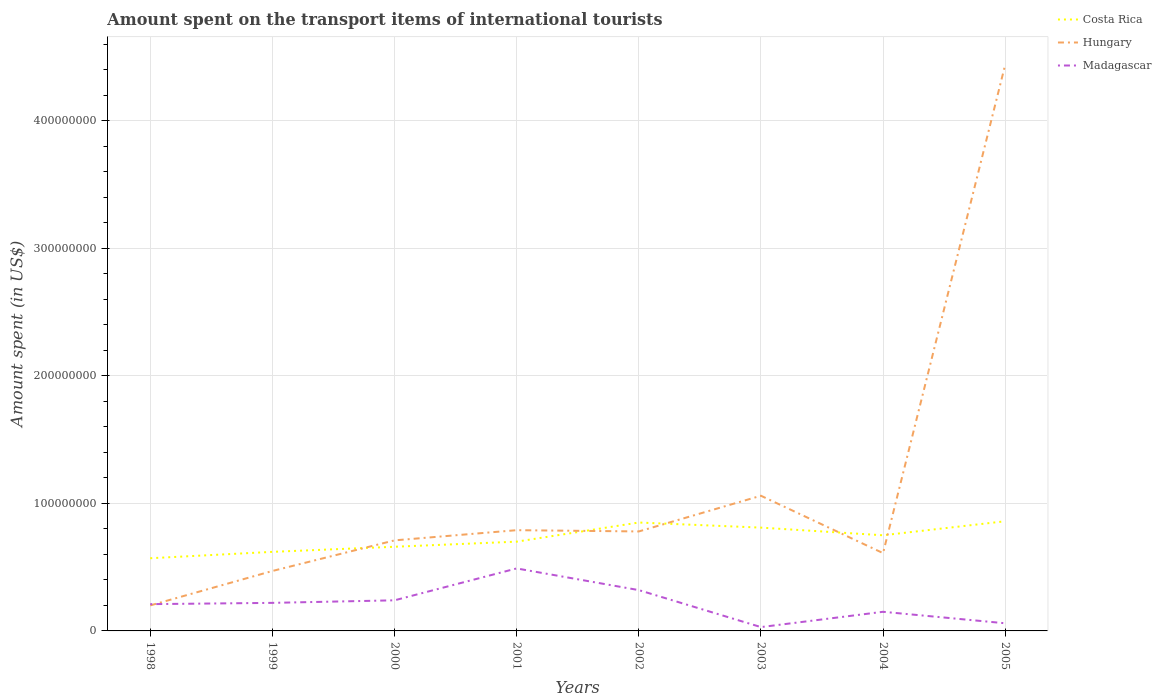Is the number of lines equal to the number of legend labels?
Ensure brevity in your answer.  Yes. Across all years, what is the maximum amount spent on the transport items of international tourists in Madagascar?
Your answer should be compact. 3.00e+06. In which year was the amount spent on the transport items of international tourists in Costa Rica maximum?
Give a very brief answer. 1998. What is the total amount spent on the transport items of international tourists in Costa Rica in the graph?
Give a very brief answer. 6.00e+06. What is the difference between the highest and the second highest amount spent on the transport items of international tourists in Madagascar?
Provide a succinct answer. 4.60e+07. Is the amount spent on the transport items of international tourists in Madagascar strictly greater than the amount spent on the transport items of international tourists in Hungary over the years?
Provide a short and direct response. No. How many lines are there?
Provide a succinct answer. 3. What is the difference between two consecutive major ticks on the Y-axis?
Offer a very short reply. 1.00e+08. Does the graph contain grids?
Keep it short and to the point. Yes. How are the legend labels stacked?
Ensure brevity in your answer.  Vertical. What is the title of the graph?
Offer a very short reply. Amount spent on the transport items of international tourists. Does "Dominica" appear as one of the legend labels in the graph?
Your answer should be compact. No. What is the label or title of the X-axis?
Make the answer very short. Years. What is the label or title of the Y-axis?
Ensure brevity in your answer.  Amount spent (in US$). What is the Amount spent (in US$) in Costa Rica in 1998?
Make the answer very short. 5.70e+07. What is the Amount spent (in US$) in Hungary in 1998?
Ensure brevity in your answer.  2.00e+07. What is the Amount spent (in US$) of Madagascar in 1998?
Offer a terse response. 2.10e+07. What is the Amount spent (in US$) of Costa Rica in 1999?
Offer a terse response. 6.20e+07. What is the Amount spent (in US$) of Hungary in 1999?
Your answer should be very brief. 4.70e+07. What is the Amount spent (in US$) of Madagascar in 1999?
Your response must be concise. 2.20e+07. What is the Amount spent (in US$) in Costa Rica in 2000?
Provide a succinct answer. 6.60e+07. What is the Amount spent (in US$) in Hungary in 2000?
Your response must be concise. 7.10e+07. What is the Amount spent (in US$) of Madagascar in 2000?
Offer a very short reply. 2.40e+07. What is the Amount spent (in US$) of Costa Rica in 2001?
Your answer should be very brief. 7.00e+07. What is the Amount spent (in US$) of Hungary in 2001?
Give a very brief answer. 7.90e+07. What is the Amount spent (in US$) in Madagascar in 2001?
Ensure brevity in your answer.  4.90e+07. What is the Amount spent (in US$) in Costa Rica in 2002?
Offer a terse response. 8.50e+07. What is the Amount spent (in US$) of Hungary in 2002?
Give a very brief answer. 7.80e+07. What is the Amount spent (in US$) of Madagascar in 2002?
Offer a terse response. 3.20e+07. What is the Amount spent (in US$) of Costa Rica in 2003?
Keep it short and to the point. 8.10e+07. What is the Amount spent (in US$) of Hungary in 2003?
Make the answer very short. 1.06e+08. What is the Amount spent (in US$) in Madagascar in 2003?
Your response must be concise. 3.00e+06. What is the Amount spent (in US$) in Costa Rica in 2004?
Keep it short and to the point. 7.50e+07. What is the Amount spent (in US$) in Hungary in 2004?
Your answer should be compact. 6.10e+07. What is the Amount spent (in US$) of Madagascar in 2004?
Your answer should be compact. 1.50e+07. What is the Amount spent (in US$) in Costa Rica in 2005?
Your answer should be compact. 8.60e+07. What is the Amount spent (in US$) of Hungary in 2005?
Make the answer very short. 4.44e+08. Across all years, what is the maximum Amount spent (in US$) in Costa Rica?
Provide a short and direct response. 8.60e+07. Across all years, what is the maximum Amount spent (in US$) of Hungary?
Your response must be concise. 4.44e+08. Across all years, what is the maximum Amount spent (in US$) in Madagascar?
Your answer should be very brief. 4.90e+07. Across all years, what is the minimum Amount spent (in US$) of Costa Rica?
Provide a succinct answer. 5.70e+07. Across all years, what is the minimum Amount spent (in US$) in Hungary?
Your answer should be compact. 2.00e+07. Across all years, what is the minimum Amount spent (in US$) in Madagascar?
Offer a terse response. 3.00e+06. What is the total Amount spent (in US$) in Costa Rica in the graph?
Provide a short and direct response. 5.82e+08. What is the total Amount spent (in US$) of Hungary in the graph?
Your response must be concise. 9.06e+08. What is the total Amount spent (in US$) of Madagascar in the graph?
Your response must be concise. 1.72e+08. What is the difference between the Amount spent (in US$) in Costa Rica in 1998 and that in 1999?
Provide a short and direct response. -5.00e+06. What is the difference between the Amount spent (in US$) of Hungary in 1998 and that in 1999?
Your answer should be very brief. -2.70e+07. What is the difference between the Amount spent (in US$) of Costa Rica in 1998 and that in 2000?
Keep it short and to the point. -9.00e+06. What is the difference between the Amount spent (in US$) in Hungary in 1998 and that in 2000?
Provide a succinct answer. -5.10e+07. What is the difference between the Amount spent (in US$) of Madagascar in 1998 and that in 2000?
Offer a very short reply. -3.00e+06. What is the difference between the Amount spent (in US$) in Costa Rica in 1998 and that in 2001?
Keep it short and to the point. -1.30e+07. What is the difference between the Amount spent (in US$) of Hungary in 1998 and that in 2001?
Offer a terse response. -5.90e+07. What is the difference between the Amount spent (in US$) of Madagascar in 1998 and that in 2001?
Provide a short and direct response. -2.80e+07. What is the difference between the Amount spent (in US$) in Costa Rica in 1998 and that in 2002?
Offer a very short reply. -2.80e+07. What is the difference between the Amount spent (in US$) in Hungary in 1998 and that in 2002?
Make the answer very short. -5.80e+07. What is the difference between the Amount spent (in US$) in Madagascar in 1998 and that in 2002?
Keep it short and to the point. -1.10e+07. What is the difference between the Amount spent (in US$) in Costa Rica in 1998 and that in 2003?
Offer a terse response. -2.40e+07. What is the difference between the Amount spent (in US$) of Hungary in 1998 and that in 2003?
Ensure brevity in your answer.  -8.60e+07. What is the difference between the Amount spent (in US$) of Madagascar in 1998 and that in 2003?
Offer a very short reply. 1.80e+07. What is the difference between the Amount spent (in US$) of Costa Rica in 1998 and that in 2004?
Ensure brevity in your answer.  -1.80e+07. What is the difference between the Amount spent (in US$) in Hungary in 1998 and that in 2004?
Provide a succinct answer. -4.10e+07. What is the difference between the Amount spent (in US$) in Costa Rica in 1998 and that in 2005?
Your answer should be very brief. -2.90e+07. What is the difference between the Amount spent (in US$) in Hungary in 1998 and that in 2005?
Your answer should be compact. -4.24e+08. What is the difference between the Amount spent (in US$) in Madagascar in 1998 and that in 2005?
Give a very brief answer. 1.50e+07. What is the difference between the Amount spent (in US$) of Costa Rica in 1999 and that in 2000?
Give a very brief answer. -4.00e+06. What is the difference between the Amount spent (in US$) in Hungary in 1999 and that in 2000?
Provide a short and direct response. -2.40e+07. What is the difference between the Amount spent (in US$) of Madagascar in 1999 and that in 2000?
Make the answer very short. -2.00e+06. What is the difference between the Amount spent (in US$) in Costa Rica in 1999 and that in 2001?
Your response must be concise. -8.00e+06. What is the difference between the Amount spent (in US$) of Hungary in 1999 and that in 2001?
Provide a succinct answer. -3.20e+07. What is the difference between the Amount spent (in US$) in Madagascar in 1999 and that in 2001?
Make the answer very short. -2.70e+07. What is the difference between the Amount spent (in US$) in Costa Rica in 1999 and that in 2002?
Your answer should be very brief. -2.30e+07. What is the difference between the Amount spent (in US$) of Hungary in 1999 and that in 2002?
Give a very brief answer. -3.10e+07. What is the difference between the Amount spent (in US$) in Madagascar in 1999 and that in 2002?
Provide a succinct answer. -1.00e+07. What is the difference between the Amount spent (in US$) in Costa Rica in 1999 and that in 2003?
Offer a very short reply. -1.90e+07. What is the difference between the Amount spent (in US$) of Hungary in 1999 and that in 2003?
Offer a very short reply. -5.90e+07. What is the difference between the Amount spent (in US$) in Madagascar in 1999 and that in 2003?
Ensure brevity in your answer.  1.90e+07. What is the difference between the Amount spent (in US$) of Costa Rica in 1999 and that in 2004?
Keep it short and to the point. -1.30e+07. What is the difference between the Amount spent (in US$) in Hungary in 1999 and that in 2004?
Ensure brevity in your answer.  -1.40e+07. What is the difference between the Amount spent (in US$) in Madagascar in 1999 and that in 2004?
Your answer should be compact. 7.00e+06. What is the difference between the Amount spent (in US$) of Costa Rica in 1999 and that in 2005?
Give a very brief answer. -2.40e+07. What is the difference between the Amount spent (in US$) in Hungary in 1999 and that in 2005?
Make the answer very short. -3.97e+08. What is the difference between the Amount spent (in US$) in Madagascar in 1999 and that in 2005?
Give a very brief answer. 1.60e+07. What is the difference between the Amount spent (in US$) in Hungary in 2000 and that in 2001?
Your answer should be very brief. -8.00e+06. What is the difference between the Amount spent (in US$) of Madagascar in 2000 and that in 2001?
Provide a short and direct response. -2.50e+07. What is the difference between the Amount spent (in US$) of Costa Rica in 2000 and that in 2002?
Keep it short and to the point. -1.90e+07. What is the difference between the Amount spent (in US$) in Hungary in 2000 and that in 2002?
Provide a short and direct response. -7.00e+06. What is the difference between the Amount spent (in US$) of Madagascar in 2000 and that in 2002?
Ensure brevity in your answer.  -8.00e+06. What is the difference between the Amount spent (in US$) of Costa Rica in 2000 and that in 2003?
Your answer should be very brief. -1.50e+07. What is the difference between the Amount spent (in US$) in Hungary in 2000 and that in 2003?
Keep it short and to the point. -3.50e+07. What is the difference between the Amount spent (in US$) in Madagascar in 2000 and that in 2003?
Provide a short and direct response. 2.10e+07. What is the difference between the Amount spent (in US$) in Costa Rica in 2000 and that in 2004?
Provide a short and direct response. -9.00e+06. What is the difference between the Amount spent (in US$) of Hungary in 2000 and that in 2004?
Offer a terse response. 1.00e+07. What is the difference between the Amount spent (in US$) in Madagascar in 2000 and that in 2004?
Your answer should be very brief. 9.00e+06. What is the difference between the Amount spent (in US$) of Costa Rica in 2000 and that in 2005?
Keep it short and to the point. -2.00e+07. What is the difference between the Amount spent (in US$) of Hungary in 2000 and that in 2005?
Offer a terse response. -3.73e+08. What is the difference between the Amount spent (in US$) in Madagascar in 2000 and that in 2005?
Provide a succinct answer. 1.80e+07. What is the difference between the Amount spent (in US$) in Costa Rica in 2001 and that in 2002?
Offer a terse response. -1.50e+07. What is the difference between the Amount spent (in US$) of Hungary in 2001 and that in 2002?
Your answer should be compact. 1.00e+06. What is the difference between the Amount spent (in US$) of Madagascar in 2001 and that in 2002?
Provide a succinct answer. 1.70e+07. What is the difference between the Amount spent (in US$) of Costa Rica in 2001 and that in 2003?
Make the answer very short. -1.10e+07. What is the difference between the Amount spent (in US$) in Hungary in 2001 and that in 2003?
Keep it short and to the point. -2.70e+07. What is the difference between the Amount spent (in US$) in Madagascar in 2001 and that in 2003?
Make the answer very short. 4.60e+07. What is the difference between the Amount spent (in US$) in Costa Rica in 2001 and that in 2004?
Provide a succinct answer. -5.00e+06. What is the difference between the Amount spent (in US$) of Hungary in 2001 and that in 2004?
Provide a short and direct response. 1.80e+07. What is the difference between the Amount spent (in US$) in Madagascar in 2001 and that in 2004?
Give a very brief answer. 3.40e+07. What is the difference between the Amount spent (in US$) of Costa Rica in 2001 and that in 2005?
Your response must be concise. -1.60e+07. What is the difference between the Amount spent (in US$) in Hungary in 2001 and that in 2005?
Your response must be concise. -3.65e+08. What is the difference between the Amount spent (in US$) in Madagascar in 2001 and that in 2005?
Make the answer very short. 4.30e+07. What is the difference between the Amount spent (in US$) in Costa Rica in 2002 and that in 2003?
Ensure brevity in your answer.  4.00e+06. What is the difference between the Amount spent (in US$) in Hungary in 2002 and that in 2003?
Give a very brief answer. -2.80e+07. What is the difference between the Amount spent (in US$) in Madagascar in 2002 and that in 2003?
Your answer should be very brief. 2.90e+07. What is the difference between the Amount spent (in US$) of Costa Rica in 2002 and that in 2004?
Keep it short and to the point. 1.00e+07. What is the difference between the Amount spent (in US$) in Hungary in 2002 and that in 2004?
Your answer should be compact. 1.70e+07. What is the difference between the Amount spent (in US$) in Madagascar in 2002 and that in 2004?
Give a very brief answer. 1.70e+07. What is the difference between the Amount spent (in US$) in Hungary in 2002 and that in 2005?
Offer a terse response. -3.66e+08. What is the difference between the Amount spent (in US$) of Madagascar in 2002 and that in 2005?
Make the answer very short. 2.60e+07. What is the difference between the Amount spent (in US$) in Costa Rica in 2003 and that in 2004?
Your answer should be very brief. 6.00e+06. What is the difference between the Amount spent (in US$) in Hungary in 2003 and that in 2004?
Your answer should be very brief. 4.50e+07. What is the difference between the Amount spent (in US$) in Madagascar in 2003 and that in 2004?
Ensure brevity in your answer.  -1.20e+07. What is the difference between the Amount spent (in US$) in Costa Rica in 2003 and that in 2005?
Your response must be concise. -5.00e+06. What is the difference between the Amount spent (in US$) in Hungary in 2003 and that in 2005?
Make the answer very short. -3.38e+08. What is the difference between the Amount spent (in US$) in Madagascar in 2003 and that in 2005?
Your response must be concise. -3.00e+06. What is the difference between the Amount spent (in US$) of Costa Rica in 2004 and that in 2005?
Make the answer very short. -1.10e+07. What is the difference between the Amount spent (in US$) of Hungary in 2004 and that in 2005?
Make the answer very short. -3.83e+08. What is the difference between the Amount spent (in US$) of Madagascar in 2004 and that in 2005?
Your answer should be compact. 9.00e+06. What is the difference between the Amount spent (in US$) of Costa Rica in 1998 and the Amount spent (in US$) of Madagascar in 1999?
Keep it short and to the point. 3.50e+07. What is the difference between the Amount spent (in US$) of Costa Rica in 1998 and the Amount spent (in US$) of Hungary in 2000?
Keep it short and to the point. -1.40e+07. What is the difference between the Amount spent (in US$) in Costa Rica in 1998 and the Amount spent (in US$) in Madagascar in 2000?
Keep it short and to the point. 3.30e+07. What is the difference between the Amount spent (in US$) of Costa Rica in 1998 and the Amount spent (in US$) of Hungary in 2001?
Your answer should be compact. -2.20e+07. What is the difference between the Amount spent (in US$) of Hungary in 1998 and the Amount spent (in US$) of Madagascar in 2001?
Provide a succinct answer. -2.90e+07. What is the difference between the Amount spent (in US$) of Costa Rica in 1998 and the Amount spent (in US$) of Hungary in 2002?
Your answer should be compact. -2.10e+07. What is the difference between the Amount spent (in US$) of Costa Rica in 1998 and the Amount spent (in US$) of Madagascar in 2002?
Offer a terse response. 2.50e+07. What is the difference between the Amount spent (in US$) of Hungary in 1998 and the Amount spent (in US$) of Madagascar in 2002?
Ensure brevity in your answer.  -1.20e+07. What is the difference between the Amount spent (in US$) of Costa Rica in 1998 and the Amount spent (in US$) of Hungary in 2003?
Give a very brief answer. -4.90e+07. What is the difference between the Amount spent (in US$) in Costa Rica in 1998 and the Amount spent (in US$) in Madagascar in 2003?
Give a very brief answer. 5.40e+07. What is the difference between the Amount spent (in US$) in Hungary in 1998 and the Amount spent (in US$) in Madagascar in 2003?
Ensure brevity in your answer.  1.70e+07. What is the difference between the Amount spent (in US$) of Costa Rica in 1998 and the Amount spent (in US$) of Madagascar in 2004?
Provide a short and direct response. 4.20e+07. What is the difference between the Amount spent (in US$) in Hungary in 1998 and the Amount spent (in US$) in Madagascar in 2004?
Offer a terse response. 5.00e+06. What is the difference between the Amount spent (in US$) in Costa Rica in 1998 and the Amount spent (in US$) in Hungary in 2005?
Make the answer very short. -3.87e+08. What is the difference between the Amount spent (in US$) of Costa Rica in 1998 and the Amount spent (in US$) of Madagascar in 2005?
Give a very brief answer. 5.10e+07. What is the difference between the Amount spent (in US$) in Hungary in 1998 and the Amount spent (in US$) in Madagascar in 2005?
Offer a terse response. 1.40e+07. What is the difference between the Amount spent (in US$) in Costa Rica in 1999 and the Amount spent (in US$) in Hungary in 2000?
Make the answer very short. -9.00e+06. What is the difference between the Amount spent (in US$) in Costa Rica in 1999 and the Amount spent (in US$) in Madagascar in 2000?
Your answer should be compact. 3.80e+07. What is the difference between the Amount spent (in US$) of Hungary in 1999 and the Amount spent (in US$) of Madagascar in 2000?
Keep it short and to the point. 2.30e+07. What is the difference between the Amount spent (in US$) of Costa Rica in 1999 and the Amount spent (in US$) of Hungary in 2001?
Offer a very short reply. -1.70e+07. What is the difference between the Amount spent (in US$) of Costa Rica in 1999 and the Amount spent (in US$) of Madagascar in 2001?
Provide a short and direct response. 1.30e+07. What is the difference between the Amount spent (in US$) of Costa Rica in 1999 and the Amount spent (in US$) of Hungary in 2002?
Your answer should be very brief. -1.60e+07. What is the difference between the Amount spent (in US$) in Costa Rica in 1999 and the Amount spent (in US$) in Madagascar in 2002?
Provide a succinct answer. 3.00e+07. What is the difference between the Amount spent (in US$) in Hungary in 1999 and the Amount spent (in US$) in Madagascar in 2002?
Offer a very short reply. 1.50e+07. What is the difference between the Amount spent (in US$) in Costa Rica in 1999 and the Amount spent (in US$) in Hungary in 2003?
Offer a terse response. -4.40e+07. What is the difference between the Amount spent (in US$) in Costa Rica in 1999 and the Amount spent (in US$) in Madagascar in 2003?
Provide a short and direct response. 5.90e+07. What is the difference between the Amount spent (in US$) of Hungary in 1999 and the Amount spent (in US$) of Madagascar in 2003?
Provide a short and direct response. 4.40e+07. What is the difference between the Amount spent (in US$) in Costa Rica in 1999 and the Amount spent (in US$) in Madagascar in 2004?
Offer a very short reply. 4.70e+07. What is the difference between the Amount spent (in US$) of Hungary in 1999 and the Amount spent (in US$) of Madagascar in 2004?
Give a very brief answer. 3.20e+07. What is the difference between the Amount spent (in US$) of Costa Rica in 1999 and the Amount spent (in US$) of Hungary in 2005?
Ensure brevity in your answer.  -3.82e+08. What is the difference between the Amount spent (in US$) of Costa Rica in 1999 and the Amount spent (in US$) of Madagascar in 2005?
Your answer should be very brief. 5.60e+07. What is the difference between the Amount spent (in US$) in Hungary in 1999 and the Amount spent (in US$) in Madagascar in 2005?
Provide a succinct answer. 4.10e+07. What is the difference between the Amount spent (in US$) in Costa Rica in 2000 and the Amount spent (in US$) in Hungary in 2001?
Provide a short and direct response. -1.30e+07. What is the difference between the Amount spent (in US$) in Costa Rica in 2000 and the Amount spent (in US$) in Madagascar in 2001?
Keep it short and to the point. 1.70e+07. What is the difference between the Amount spent (in US$) of Hungary in 2000 and the Amount spent (in US$) of Madagascar in 2001?
Ensure brevity in your answer.  2.20e+07. What is the difference between the Amount spent (in US$) in Costa Rica in 2000 and the Amount spent (in US$) in Hungary in 2002?
Provide a succinct answer. -1.20e+07. What is the difference between the Amount spent (in US$) in Costa Rica in 2000 and the Amount spent (in US$) in Madagascar in 2002?
Make the answer very short. 3.40e+07. What is the difference between the Amount spent (in US$) in Hungary in 2000 and the Amount spent (in US$) in Madagascar in 2002?
Your answer should be very brief. 3.90e+07. What is the difference between the Amount spent (in US$) of Costa Rica in 2000 and the Amount spent (in US$) of Hungary in 2003?
Make the answer very short. -4.00e+07. What is the difference between the Amount spent (in US$) in Costa Rica in 2000 and the Amount spent (in US$) in Madagascar in 2003?
Provide a short and direct response. 6.30e+07. What is the difference between the Amount spent (in US$) of Hungary in 2000 and the Amount spent (in US$) of Madagascar in 2003?
Provide a succinct answer. 6.80e+07. What is the difference between the Amount spent (in US$) in Costa Rica in 2000 and the Amount spent (in US$) in Madagascar in 2004?
Provide a succinct answer. 5.10e+07. What is the difference between the Amount spent (in US$) in Hungary in 2000 and the Amount spent (in US$) in Madagascar in 2004?
Keep it short and to the point. 5.60e+07. What is the difference between the Amount spent (in US$) of Costa Rica in 2000 and the Amount spent (in US$) of Hungary in 2005?
Provide a succinct answer. -3.78e+08. What is the difference between the Amount spent (in US$) in Costa Rica in 2000 and the Amount spent (in US$) in Madagascar in 2005?
Your answer should be compact. 6.00e+07. What is the difference between the Amount spent (in US$) in Hungary in 2000 and the Amount spent (in US$) in Madagascar in 2005?
Make the answer very short. 6.50e+07. What is the difference between the Amount spent (in US$) of Costa Rica in 2001 and the Amount spent (in US$) of Hungary in 2002?
Make the answer very short. -8.00e+06. What is the difference between the Amount spent (in US$) in Costa Rica in 2001 and the Amount spent (in US$) in Madagascar in 2002?
Offer a very short reply. 3.80e+07. What is the difference between the Amount spent (in US$) of Hungary in 2001 and the Amount spent (in US$) of Madagascar in 2002?
Provide a succinct answer. 4.70e+07. What is the difference between the Amount spent (in US$) in Costa Rica in 2001 and the Amount spent (in US$) in Hungary in 2003?
Make the answer very short. -3.60e+07. What is the difference between the Amount spent (in US$) of Costa Rica in 2001 and the Amount spent (in US$) of Madagascar in 2003?
Provide a succinct answer. 6.70e+07. What is the difference between the Amount spent (in US$) of Hungary in 2001 and the Amount spent (in US$) of Madagascar in 2003?
Make the answer very short. 7.60e+07. What is the difference between the Amount spent (in US$) of Costa Rica in 2001 and the Amount spent (in US$) of Hungary in 2004?
Make the answer very short. 9.00e+06. What is the difference between the Amount spent (in US$) in Costa Rica in 2001 and the Amount spent (in US$) in Madagascar in 2004?
Offer a very short reply. 5.50e+07. What is the difference between the Amount spent (in US$) in Hungary in 2001 and the Amount spent (in US$) in Madagascar in 2004?
Ensure brevity in your answer.  6.40e+07. What is the difference between the Amount spent (in US$) in Costa Rica in 2001 and the Amount spent (in US$) in Hungary in 2005?
Your response must be concise. -3.74e+08. What is the difference between the Amount spent (in US$) of Costa Rica in 2001 and the Amount spent (in US$) of Madagascar in 2005?
Your response must be concise. 6.40e+07. What is the difference between the Amount spent (in US$) in Hungary in 2001 and the Amount spent (in US$) in Madagascar in 2005?
Give a very brief answer. 7.30e+07. What is the difference between the Amount spent (in US$) in Costa Rica in 2002 and the Amount spent (in US$) in Hungary in 2003?
Provide a short and direct response. -2.10e+07. What is the difference between the Amount spent (in US$) of Costa Rica in 2002 and the Amount spent (in US$) of Madagascar in 2003?
Your response must be concise. 8.20e+07. What is the difference between the Amount spent (in US$) in Hungary in 2002 and the Amount spent (in US$) in Madagascar in 2003?
Your answer should be very brief. 7.50e+07. What is the difference between the Amount spent (in US$) of Costa Rica in 2002 and the Amount spent (in US$) of Hungary in 2004?
Give a very brief answer. 2.40e+07. What is the difference between the Amount spent (in US$) of Costa Rica in 2002 and the Amount spent (in US$) of Madagascar in 2004?
Your answer should be compact. 7.00e+07. What is the difference between the Amount spent (in US$) of Hungary in 2002 and the Amount spent (in US$) of Madagascar in 2004?
Your response must be concise. 6.30e+07. What is the difference between the Amount spent (in US$) of Costa Rica in 2002 and the Amount spent (in US$) of Hungary in 2005?
Keep it short and to the point. -3.59e+08. What is the difference between the Amount spent (in US$) in Costa Rica in 2002 and the Amount spent (in US$) in Madagascar in 2005?
Provide a succinct answer. 7.90e+07. What is the difference between the Amount spent (in US$) in Hungary in 2002 and the Amount spent (in US$) in Madagascar in 2005?
Your answer should be very brief. 7.20e+07. What is the difference between the Amount spent (in US$) in Costa Rica in 2003 and the Amount spent (in US$) in Hungary in 2004?
Give a very brief answer. 2.00e+07. What is the difference between the Amount spent (in US$) in Costa Rica in 2003 and the Amount spent (in US$) in Madagascar in 2004?
Your answer should be very brief. 6.60e+07. What is the difference between the Amount spent (in US$) in Hungary in 2003 and the Amount spent (in US$) in Madagascar in 2004?
Your response must be concise. 9.10e+07. What is the difference between the Amount spent (in US$) of Costa Rica in 2003 and the Amount spent (in US$) of Hungary in 2005?
Provide a short and direct response. -3.63e+08. What is the difference between the Amount spent (in US$) of Costa Rica in 2003 and the Amount spent (in US$) of Madagascar in 2005?
Ensure brevity in your answer.  7.50e+07. What is the difference between the Amount spent (in US$) of Hungary in 2003 and the Amount spent (in US$) of Madagascar in 2005?
Your answer should be compact. 1.00e+08. What is the difference between the Amount spent (in US$) of Costa Rica in 2004 and the Amount spent (in US$) of Hungary in 2005?
Your answer should be compact. -3.69e+08. What is the difference between the Amount spent (in US$) of Costa Rica in 2004 and the Amount spent (in US$) of Madagascar in 2005?
Offer a very short reply. 6.90e+07. What is the difference between the Amount spent (in US$) in Hungary in 2004 and the Amount spent (in US$) in Madagascar in 2005?
Ensure brevity in your answer.  5.50e+07. What is the average Amount spent (in US$) in Costa Rica per year?
Your answer should be very brief. 7.28e+07. What is the average Amount spent (in US$) in Hungary per year?
Make the answer very short. 1.13e+08. What is the average Amount spent (in US$) of Madagascar per year?
Your answer should be compact. 2.15e+07. In the year 1998, what is the difference between the Amount spent (in US$) of Costa Rica and Amount spent (in US$) of Hungary?
Your answer should be compact. 3.70e+07. In the year 1998, what is the difference between the Amount spent (in US$) in Costa Rica and Amount spent (in US$) in Madagascar?
Ensure brevity in your answer.  3.60e+07. In the year 1998, what is the difference between the Amount spent (in US$) in Hungary and Amount spent (in US$) in Madagascar?
Your response must be concise. -1.00e+06. In the year 1999, what is the difference between the Amount spent (in US$) in Costa Rica and Amount spent (in US$) in Hungary?
Your answer should be compact. 1.50e+07. In the year 1999, what is the difference between the Amount spent (in US$) in Costa Rica and Amount spent (in US$) in Madagascar?
Ensure brevity in your answer.  4.00e+07. In the year 1999, what is the difference between the Amount spent (in US$) in Hungary and Amount spent (in US$) in Madagascar?
Give a very brief answer. 2.50e+07. In the year 2000, what is the difference between the Amount spent (in US$) in Costa Rica and Amount spent (in US$) in Hungary?
Your response must be concise. -5.00e+06. In the year 2000, what is the difference between the Amount spent (in US$) of Costa Rica and Amount spent (in US$) of Madagascar?
Provide a short and direct response. 4.20e+07. In the year 2000, what is the difference between the Amount spent (in US$) of Hungary and Amount spent (in US$) of Madagascar?
Offer a terse response. 4.70e+07. In the year 2001, what is the difference between the Amount spent (in US$) in Costa Rica and Amount spent (in US$) in Hungary?
Ensure brevity in your answer.  -9.00e+06. In the year 2001, what is the difference between the Amount spent (in US$) of Costa Rica and Amount spent (in US$) of Madagascar?
Make the answer very short. 2.10e+07. In the year 2001, what is the difference between the Amount spent (in US$) in Hungary and Amount spent (in US$) in Madagascar?
Ensure brevity in your answer.  3.00e+07. In the year 2002, what is the difference between the Amount spent (in US$) in Costa Rica and Amount spent (in US$) in Hungary?
Offer a terse response. 7.00e+06. In the year 2002, what is the difference between the Amount spent (in US$) in Costa Rica and Amount spent (in US$) in Madagascar?
Offer a terse response. 5.30e+07. In the year 2002, what is the difference between the Amount spent (in US$) of Hungary and Amount spent (in US$) of Madagascar?
Provide a short and direct response. 4.60e+07. In the year 2003, what is the difference between the Amount spent (in US$) of Costa Rica and Amount spent (in US$) of Hungary?
Offer a very short reply. -2.50e+07. In the year 2003, what is the difference between the Amount spent (in US$) in Costa Rica and Amount spent (in US$) in Madagascar?
Provide a succinct answer. 7.80e+07. In the year 2003, what is the difference between the Amount spent (in US$) of Hungary and Amount spent (in US$) of Madagascar?
Provide a short and direct response. 1.03e+08. In the year 2004, what is the difference between the Amount spent (in US$) of Costa Rica and Amount spent (in US$) of Hungary?
Offer a terse response. 1.40e+07. In the year 2004, what is the difference between the Amount spent (in US$) of Costa Rica and Amount spent (in US$) of Madagascar?
Your answer should be compact. 6.00e+07. In the year 2004, what is the difference between the Amount spent (in US$) of Hungary and Amount spent (in US$) of Madagascar?
Make the answer very short. 4.60e+07. In the year 2005, what is the difference between the Amount spent (in US$) in Costa Rica and Amount spent (in US$) in Hungary?
Ensure brevity in your answer.  -3.58e+08. In the year 2005, what is the difference between the Amount spent (in US$) of Costa Rica and Amount spent (in US$) of Madagascar?
Offer a very short reply. 8.00e+07. In the year 2005, what is the difference between the Amount spent (in US$) of Hungary and Amount spent (in US$) of Madagascar?
Your response must be concise. 4.38e+08. What is the ratio of the Amount spent (in US$) in Costa Rica in 1998 to that in 1999?
Offer a very short reply. 0.92. What is the ratio of the Amount spent (in US$) of Hungary in 1998 to that in 1999?
Your answer should be compact. 0.43. What is the ratio of the Amount spent (in US$) of Madagascar in 1998 to that in 1999?
Your answer should be compact. 0.95. What is the ratio of the Amount spent (in US$) in Costa Rica in 1998 to that in 2000?
Your response must be concise. 0.86. What is the ratio of the Amount spent (in US$) in Hungary in 1998 to that in 2000?
Your answer should be compact. 0.28. What is the ratio of the Amount spent (in US$) in Costa Rica in 1998 to that in 2001?
Your answer should be compact. 0.81. What is the ratio of the Amount spent (in US$) of Hungary in 1998 to that in 2001?
Your response must be concise. 0.25. What is the ratio of the Amount spent (in US$) of Madagascar in 1998 to that in 2001?
Ensure brevity in your answer.  0.43. What is the ratio of the Amount spent (in US$) in Costa Rica in 1998 to that in 2002?
Give a very brief answer. 0.67. What is the ratio of the Amount spent (in US$) in Hungary in 1998 to that in 2002?
Your answer should be very brief. 0.26. What is the ratio of the Amount spent (in US$) of Madagascar in 1998 to that in 2002?
Your answer should be compact. 0.66. What is the ratio of the Amount spent (in US$) of Costa Rica in 1998 to that in 2003?
Ensure brevity in your answer.  0.7. What is the ratio of the Amount spent (in US$) in Hungary in 1998 to that in 2003?
Give a very brief answer. 0.19. What is the ratio of the Amount spent (in US$) of Madagascar in 1998 to that in 2003?
Your response must be concise. 7. What is the ratio of the Amount spent (in US$) in Costa Rica in 1998 to that in 2004?
Offer a very short reply. 0.76. What is the ratio of the Amount spent (in US$) of Hungary in 1998 to that in 2004?
Keep it short and to the point. 0.33. What is the ratio of the Amount spent (in US$) in Costa Rica in 1998 to that in 2005?
Your answer should be very brief. 0.66. What is the ratio of the Amount spent (in US$) in Hungary in 1998 to that in 2005?
Keep it short and to the point. 0.04. What is the ratio of the Amount spent (in US$) of Madagascar in 1998 to that in 2005?
Your response must be concise. 3.5. What is the ratio of the Amount spent (in US$) in Costa Rica in 1999 to that in 2000?
Provide a succinct answer. 0.94. What is the ratio of the Amount spent (in US$) of Hungary in 1999 to that in 2000?
Keep it short and to the point. 0.66. What is the ratio of the Amount spent (in US$) in Madagascar in 1999 to that in 2000?
Provide a succinct answer. 0.92. What is the ratio of the Amount spent (in US$) in Costa Rica in 1999 to that in 2001?
Make the answer very short. 0.89. What is the ratio of the Amount spent (in US$) in Hungary in 1999 to that in 2001?
Your answer should be very brief. 0.59. What is the ratio of the Amount spent (in US$) in Madagascar in 1999 to that in 2001?
Ensure brevity in your answer.  0.45. What is the ratio of the Amount spent (in US$) of Costa Rica in 1999 to that in 2002?
Provide a succinct answer. 0.73. What is the ratio of the Amount spent (in US$) of Hungary in 1999 to that in 2002?
Make the answer very short. 0.6. What is the ratio of the Amount spent (in US$) of Madagascar in 1999 to that in 2002?
Give a very brief answer. 0.69. What is the ratio of the Amount spent (in US$) of Costa Rica in 1999 to that in 2003?
Offer a very short reply. 0.77. What is the ratio of the Amount spent (in US$) in Hungary in 1999 to that in 2003?
Offer a terse response. 0.44. What is the ratio of the Amount spent (in US$) of Madagascar in 1999 to that in 2003?
Give a very brief answer. 7.33. What is the ratio of the Amount spent (in US$) in Costa Rica in 1999 to that in 2004?
Offer a very short reply. 0.83. What is the ratio of the Amount spent (in US$) of Hungary in 1999 to that in 2004?
Your answer should be compact. 0.77. What is the ratio of the Amount spent (in US$) in Madagascar in 1999 to that in 2004?
Give a very brief answer. 1.47. What is the ratio of the Amount spent (in US$) of Costa Rica in 1999 to that in 2005?
Keep it short and to the point. 0.72. What is the ratio of the Amount spent (in US$) of Hungary in 1999 to that in 2005?
Give a very brief answer. 0.11. What is the ratio of the Amount spent (in US$) of Madagascar in 1999 to that in 2005?
Offer a very short reply. 3.67. What is the ratio of the Amount spent (in US$) in Costa Rica in 2000 to that in 2001?
Provide a succinct answer. 0.94. What is the ratio of the Amount spent (in US$) in Hungary in 2000 to that in 2001?
Provide a succinct answer. 0.9. What is the ratio of the Amount spent (in US$) in Madagascar in 2000 to that in 2001?
Keep it short and to the point. 0.49. What is the ratio of the Amount spent (in US$) in Costa Rica in 2000 to that in 2002?
Your answer should be very brief. 0.78. What is the ratio of the Amount spent (in US$) in Hungary in 2000 to that in 2002?
Make the answer very short. 0.91. What is the ratio of the Amount spent (in US$) of Costa Rica in 2000 to that in 2003?
Your answer should be very brief. 0.81. What is the ratio of the Amount spent (in US$) of Hungary in 2000 to that in 2003?
Your answer should be compact. 0.67. What is the ratio of the Amount spent (in US$) in Madagascar in 2000 to that in 2003?
Ensure brevity in your answer.  8. What is the ratio of the Amount spent (in US$) in Costa Rica in 2000 to that in 2004?
Your answer should be compact. 0.88. What is the ratio of the Amount spent (in US$) in Hungary in 2000 to that in 2004?
Provide a succinct answer. 1.16. What is the ratio of the Amount spent (in US$) of Costa Rica in 2000 to that in 2005?
Ensure brevity in your answer.  0.77. What is the ratio of the Amount spent (in US$) of Hungary in 2000 to that in 2005?
Provide a succinct answer. 0.16. What is the ratio of the Amount spent (in US$) in Madagascar in 2000 to that in 2005?
Offer a very short reply. 4. What is the ratio of the Amount spent (in US$) in Costa Rica in 2001 to that in 2002?
Make the answer very short. 0.82. What is the ratio of the Amount spent (in US$) in Hungary in 2001 to that in 2002?
Your response must be concise. 1.01. What is the ratio of the Amount spent (in US$) in Madagascar in 2001 to that in 2002?
Provide a succinct answer. 1.53. What is the ratio of the Amount spent (in US$) in Costa Rica in 2001 to that in 2003?
Your answer should be very brief. 0.86. What is the ratio of the Amount spent (in US$) in Hungary in 2001 to that in 2003?
Your answer should be compact. 0.75. What is the ratio of the Amount spent (in US$) in Madagascar in 2001 to that in 2003?
Offer a terse response. 16.33. What is the ratio of the Amount spent (in US$) of Costa Rica in 2001 to that in 2004?
Ensure brevity in your answer.  0.93. What is the ratio of the Amount spent (in US$) in Hungary in 2001 to that in 2004?
Your answer should be very brief. 1.3. What is the ratio of the Amount spent (in US$) of Madagascar in 2001 to that in 2004?
Give a very brief answer. 3.27. What is the ratio of the Amount spent (in US$) in Costa Rica in 2001 to that in 2005?
Keep it short and to the point. 0.81. What is the ratio of the Amount spent (in US$) of Hungary in 2001 to that in 2005?
Ensure brevity in your answer.  0.18. What is the ratio of the Amount spent (in US$) of Madagascar in 2001 to that in 2005?
Make the answer very short. 8.17. What is the ratio of the Amount spent (in US$) of Costa Rica in 2002 to that in 2003?
Keep it short and to the point. 1.05. What is the ratio of the Amount spent (in US$) of Hungary in 2002 to that in 2003?
Provide a short and direct response. 0.74. What is the ratio of the Amount spent (in US$) of Madagascar in 2002 to that in 2003?
Give a very brief answer. 10.67. What is the ratio of the Amount spent (in US$) of Costa Rica in 2002 to that in 2004?
Offer a terse response. 1.13. What is the ratio of the Amount spent (in US$) of Hungary in 2002 to that in 2004?
Provide a short and direct response. 1.28. What is the ratio of the Amount spent (in US$) in Madagascar in 2002 to that in 2004?
Ensure brevity in your answer.  2.13. What is the ratio of the Amount spent (in US$) in Costa Rica in 2002 to that in 2005?
Give a very brief answer. 0.99. What is the ratio of the Amount spent (in US$) in Hungary in 2002 to that in 2005?
Offer a very short reply. 0.18. What is the ratio of the Amount spent (in US$) in Madagascar in 2002 to that in 2005?
Make the answer very short. 5.33. What is the ratio of the Amount spent (in US$) in Hungary in 2003 to that in 2004?
Give a very brief answer. 1.74. What is the ratio of the Amount spent (in US$) in Costa Rica in 2003 to that in 2005?
Provide a short and direct response. 0.94. What is the ratio of the Amount spent (in US$) of Hungary in 2003 to that in 2005?
Provide a short and direct response. 0.24. What is the ratio of the Amount spent (in US$) of Madagascar in 2003 to that in 2005?
Your answer should be compact. 0.5. What is the ratio of the Amount spent (in US$) of Costa Rica in 2004 to that in 2005?
Offer a very short reply. 0.87. What is the ratio of the Amount spent (in US$) in Hungary in 2004 to that in 2005?
Provide a short and direct response. 0.14. What is the difference between the highest and the second highest Amount spent (in US$) in Hungary?
Give a very brief answer. 3.38e+08. What is the difference between the highest and the second highest Amount spent (in US$) in Madagascar?
Your answer should be very brief. 1.70e+07. What is the difference between the highest and the lowest Amount spent (in US$) in Costa Rica?
Offer a terse response. 2.90e+07. What is the difference between the highest and the lowest Amount spent (in US$) of Hungary?
Your answer should be very brief. 4.24e+08. What is the difference between the highest and the lowest Amount spent (in US$) in Madagascar?
Your response must be concise. 4.60e+07. 